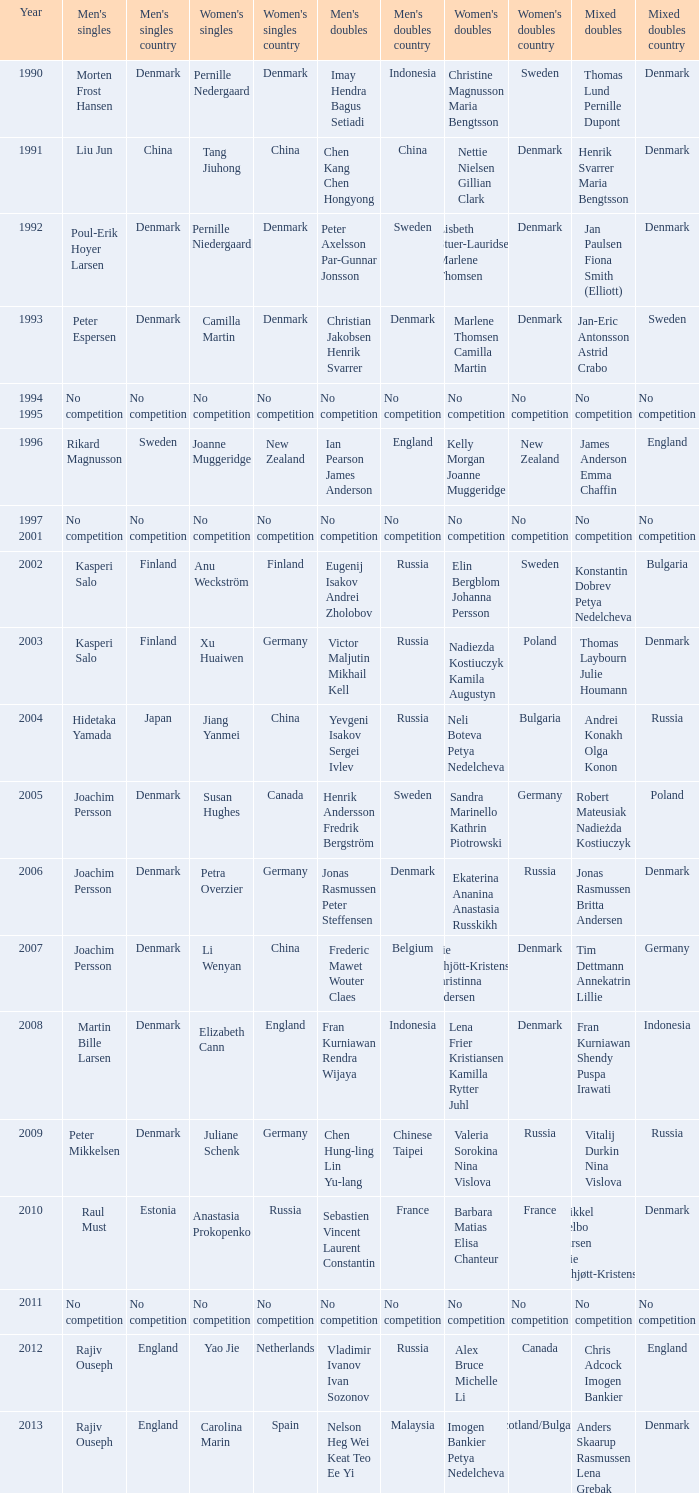Give me the full table as a dictionary. {'header': ['Year', "Men's singles", "Men's singles country", "Women's singles", "Women's singles country", "Men's doubles", "Men's doubles country", "Women's doubles", "Women's doubles country", 'Mixed doubles', 'Mixed doubles country'], 'rows': [['1990', 'Morten Frost Hansen', 'Denmark', 'Pernille Nedergaard', 'Denmark', 'Imay Hendra Bagus Setiadi', 'Indonesia', 'Christine Magnusson Maria Bengtsson', 'Sweden', 'Thomas Lund Pernille Dupont', 'Denmark'], ['1991', 'Liu Jun', 'China', 'Tang Jiuhong', 'China', 'Chen Kang Chen Hongyong', 'China', 'Nettie Nielsen Gillian Clark', 'Denmark', 'Henrik Svarrer Maria Bengtsson', 'Denmark'], ['1992', 'Poul-Erik Hoyer Larsen', 'Denmark', 'Pernille Niedergaard', 'Denmark', 'Peter Axelsson Par-Gunnar Jonsson', 'Sweden', 'Lisbeth Stuer-Lauridsen Marlene Thomsen', 'Denmark', 'Jan Paulsen Fiona Smith (Elliott)', 'Denmark'], ['1993', 'Peter Espersen', 'Denmark', 'Camilla Martin', 'Denmark', 'Christian Jakobsen Henrik Svarrer', 'Denmark', 'Marlene Thomsen Camilla Martin', 'Denmark', 'Jan-Eric Antonsson Astrid Crabo', 'Sweden'], ['1994 1995', 'No competition', 'No competition', 'No competition', 'No competition', 'No competition', 'No competition', 'No competition', 'No competition', 'No competition', 'No competition'], ['1996', 'Rikard Magnusson', 'Sweden', 'Joanne Muggeridge', 'New Zealand', 'Ian Pearson James Anderson', 'England', 'Kelly Morgan Joanne Muggeridge', 'New Zealand', 'James Anderson Emma Chaffin', 'England'], ['1997 2001', 'No competition', 'No competition', 'No competition', 'No competition', 'No competition', 'No competition', 'No competition', 'No competition', 'No competition', 'No competition'], ['2002', 'Kasperi Salo', 'Finland', 'Anu Weckström', 'Finland', 'Eugenij Isakov Andrei Zholobov', 'Russia', 'Elin Bergblom Johanna Persson', 'Sweden', 'Konstantin Dobrev Petya Nedelcheva', 'Bulgaria'], ['2003', 'Kasperi Salo', 'Finland', 'Xu Huaiwen', 'Germany', 'Victor Maljutin Mikhail Kell', 'Russia', 'Nadiezda Kostiuczyk Kamila Augustyn', 'Poland', 'Thomas Laybourn Julie Houmann', 'Denmark'], ['2004', 'Hidetaka Yamada', 'Japan', 'Jiang Yanmei', 'China', 'Yevgeni Isakov Sergei Ivlev', 'Russia', 'Neli Boteva Petya Nedelcheva', 'Bulgaria', 'Andrei Konakh Olga Konon', 'Russia'], ['2005', 'Joachim Persson', 'Denmark', 'Susan Hughes', 'Canada', 'Henrik Andersson Fredrik Bergström', 'Sweden', 'Sandra Marinello Kathrin Piotrowski', 'Germany', 'Robert Mateusiak Nadieżda Kostiuczyk', 'Poland'], ['2006', 'Joachim Persson', 'Denmark', 'Petra Overzier', 'Germany', 'Jonas Rasmussen Peter Steffensen', 'Denmark', 'Ekaterina Ananina Anastasia Russkikh', 'Russia', 'Jonas Rasmussen Britta Andersen', 'Denmark'], ['2007', 'Joachim Persson', 'Denmark', 'Li Wenyan', 'China', 'Frederic Mawet Wouter Claes', 'Belgium', 'Mie Schjött-Kristensen Christinna Pedersen', 'Denmark', 'Tim Dettmann Annekatrin Lillie', 'Germany'], ['2008', 'Martin Bille Larsen', 'Denmark', 'Elizabeth Cann', 'England', 'Fran Kurniawan Rendra Wijaya', 'Indonesia', 'Lena Frier Kristiansen Kamilla Rytter Juhl', 'Denmark', 'Fran Kurniawan Shendy Puspa Irawati', 'Indonesia'], ['2009', 'Peter Mikkelsen', 'Denmark', 'Juliane Schenk', 'Germany', 'Chen Hung-ling Lin Yu-lang', 'Chinese Taipei', 'Valeria Sorokina Nina Vislova', 'Russia', 'Vitalij Durkin Nina Vislova', 'Russia'], ['2010', 'Raul Must', 'Estonia', 'Anastasia Prokopenko', 'Russia', 'Sebastien Vincent Laurent Constantin', 'France', 'Barbara Matias Elisa Chanteur', 'France', 'Mikkel Delbo Larsen Mie Schjøtt-Kristensen', 'Denmark'], ['2011', 'No competition', 'No competition', 'No competition', 'No competition', 'No competition', 'No competition', 'No competition', 'No competition', 'No competition', 'No competition'], ['2012', 'Rajiv Ouseph', 'England', 'Yao Jie', 'Netherlands', 'Vladimir Ivanov Ivan Sozonov', 'Russia', 'Alex Bruce Michelle Li', 'Canada', 'Chris Adcock Imogen Bankier', 'England'], ['2013', 'Rajiv Ouseph', 'England', 'Carolina Marin', 'Spain', 'Nelson Heg Wei Keat Teo Ee Yi', 'Malaysia', 'Imogen Bankier Petya Nedelcheva', 'Scotland/Bulgaria', 'Anders Skaarup Rasmussen Lena Grebak', 'Denmark']]} In 2007, who were the winners of the mixed doubles? Tim Dettmann Annekatrin Lillie. 